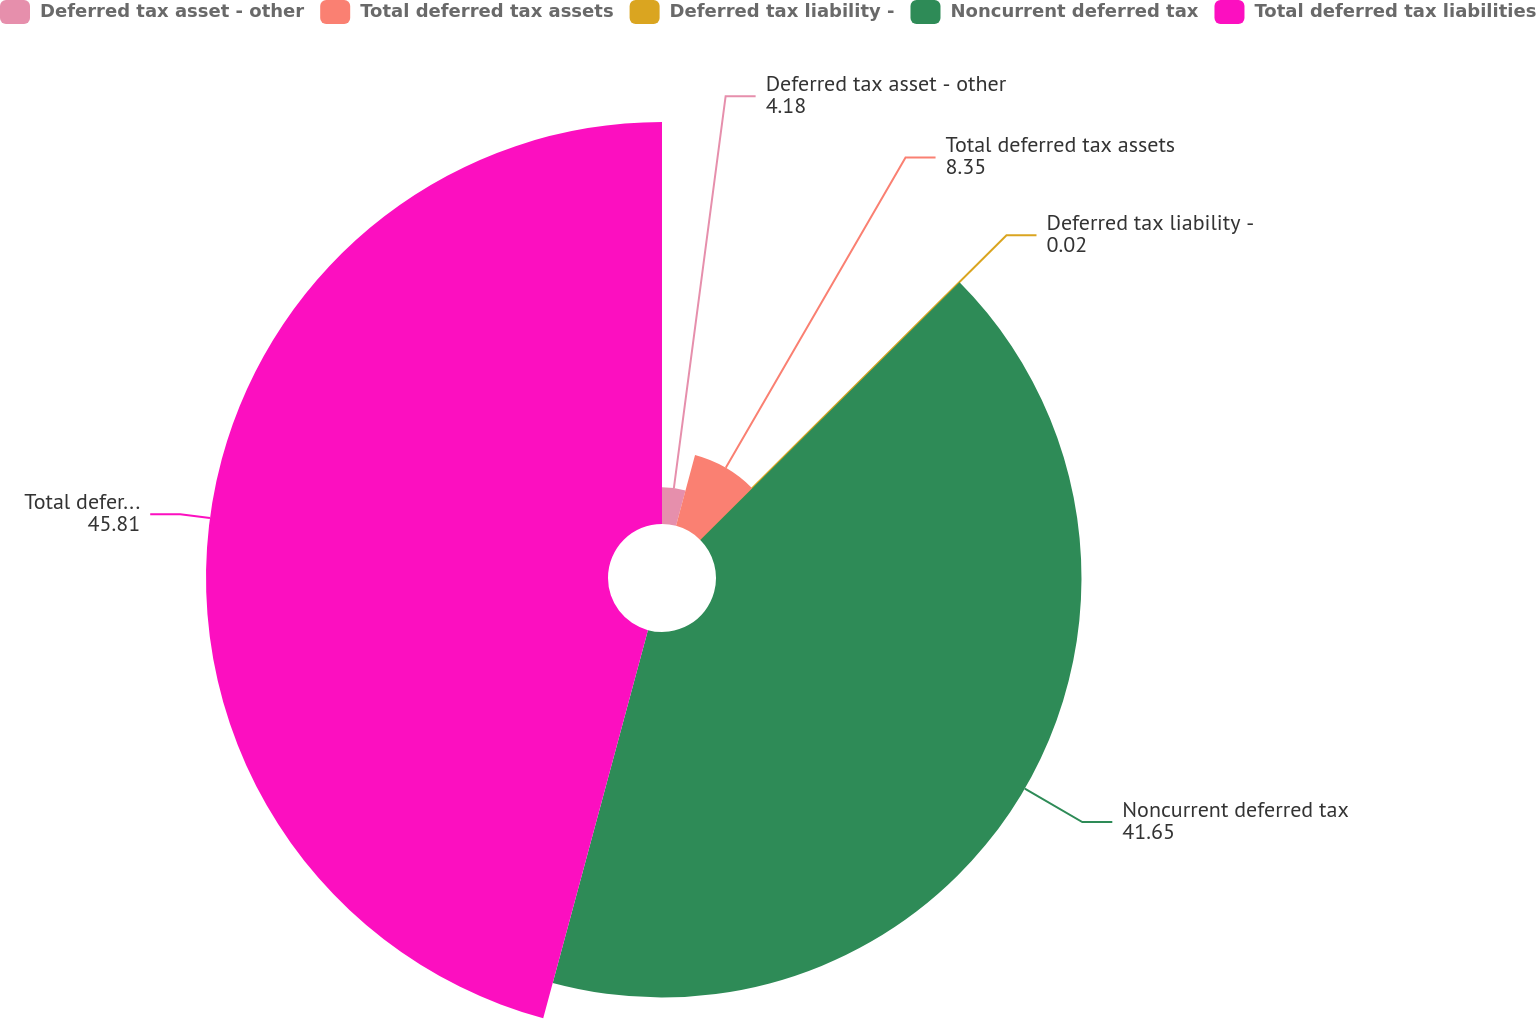Convert chart. <chart><loc_0><loc_0><loc_500><loc_500><pie_chart><fcel>Deferred tax asset - other<fcel>Total deferred tax assets<fcel>Deferred tax liability -<fcel>Noncurrent deferred tax<fcel>Total deferred tax liabilities<nl><fcel>4.18%<fcel>8.35%<fcel>0.02%<fcel>41.65%<fcel>45.81%<nl></chart> 